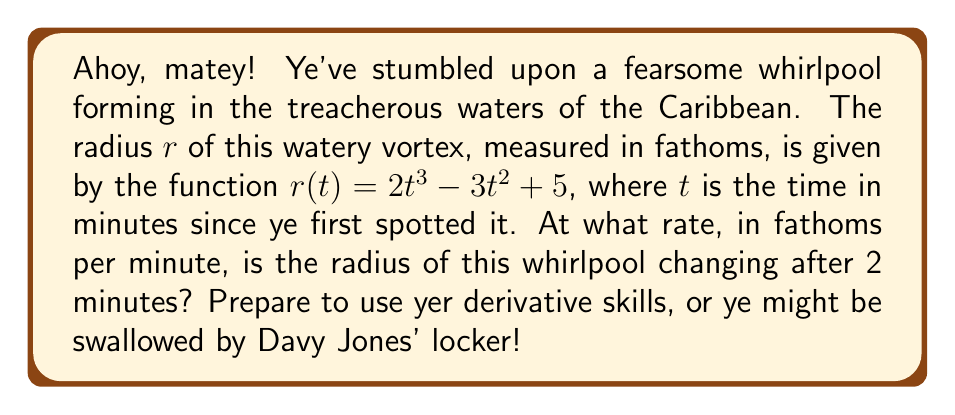Can you solve this math problem? To solve this problem, we need to follow these steps:

1) The rate at which the radius is changing is given by the derivative of $r(t)$ with respect to $t$.

2) Let's find the derivative $r'(t)$ using the power rule:
   $$r'(t) = \frac{d}{dt}(2t^3 - 3t^2 + 5)$$
   $$r'(t) = 6t^2 - 6t$$

3) Now that we have the derivative, we need to evaluate it at $t = 2$ minutes:
   $$r'(2) = 6(2)^2 - 6(2)$$
   $$r'(2) = 6(4) - 12$$
   $$r'(2) = 24 - 12 = 12$$

4) Therefore, after 2 minutes, the radius is changing at a rate of 12 fathoms per minute.
Answer: $12$ fathoms/minute 